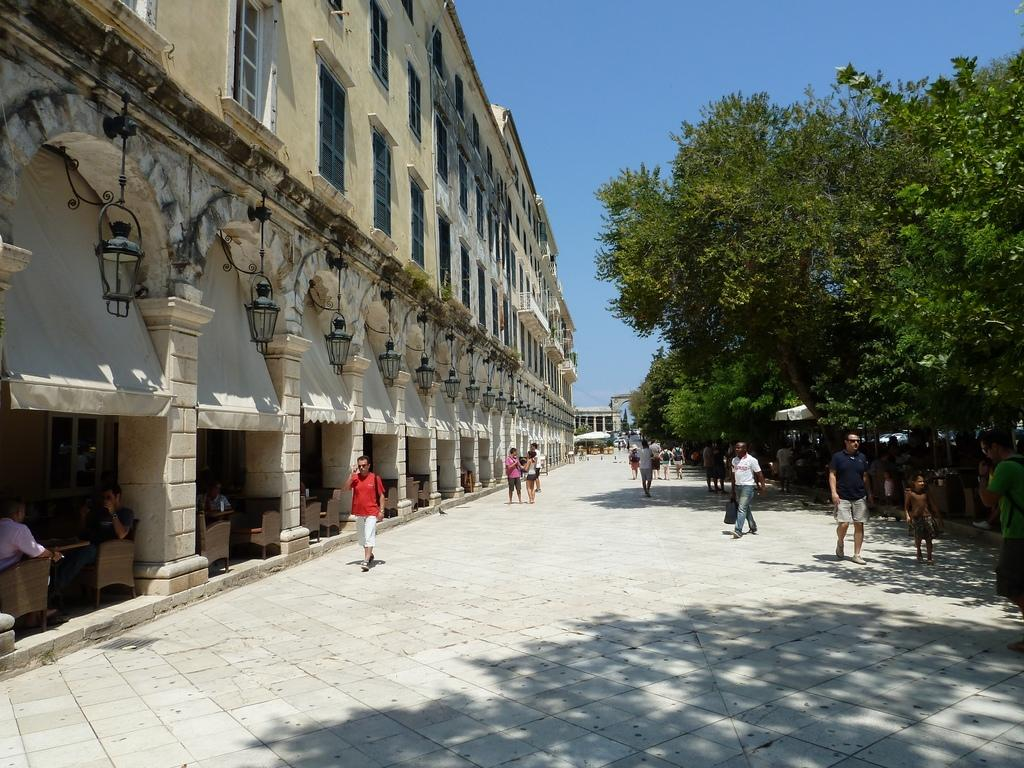What can be seen beside the building in the image? There are persons beside the building in the image. What type of vegetation is on the right side of the image? There are trees on the right side of the image. What is visible in the top right of the image? There is a sky visible in the top right of the image. What type of news can be seen on the tray in the image? There is no tray present in the image, so it is not possible to determine what type of news might be on it. 